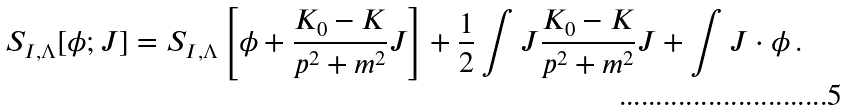Convert formula to latex. <formula><loc_0><loc_0><loc_500><loc_500>S _ { I , \Lambda } [ \phi ; J ] = S _ { I , \Lambda } \left [ \phi + \frac { K _ { 0 } - K } { p ^ { 2 } + m ^ { 2 } } J \right ] + \frac { 1 } { 2 } \int J \frac { K _ { 0 } - K } { p ^ { 2 } + m ^ { 2 } } J + \int J \cdot \phi \, .</formula> 